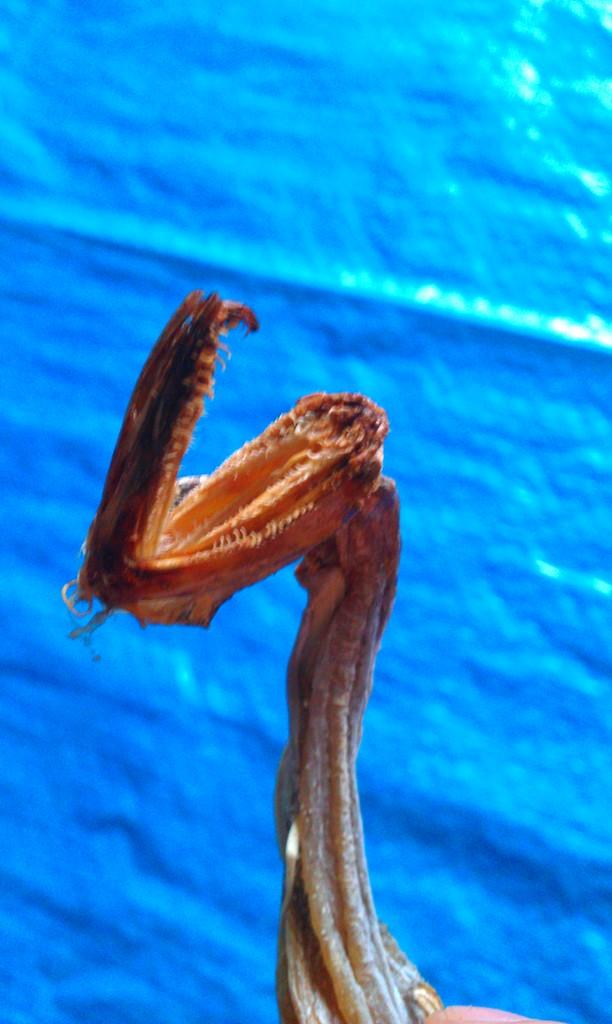What type of bones are visible in the image? There are snake bones in the image. What color is the background of the image? The background of the image is blue. How many clocks are present in the image? There are no clocks visible in the image. What type of plantation can be seen in the background of the image? There is no plantation present in the image; the background is blue. 